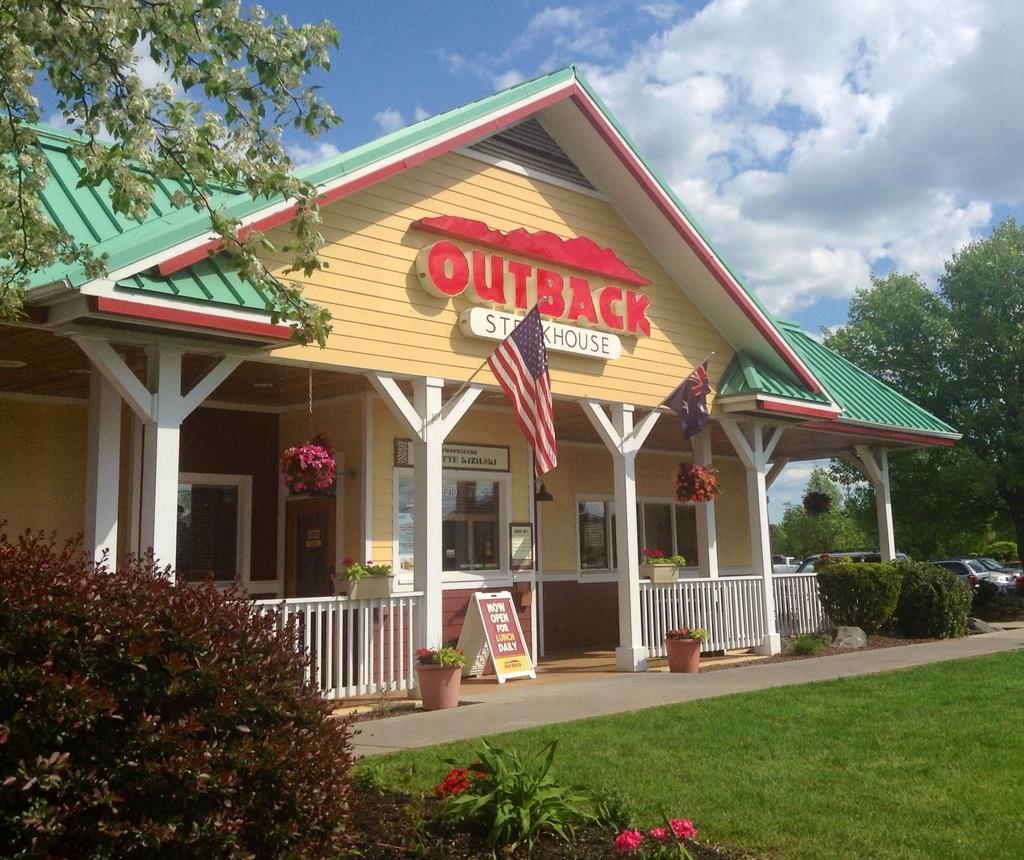Could you give a brief overview of what you see in this image? Here we can see grass, plants, flowers, cars, flags, boards, fence, trees, and a house. In the background there is sky with clouds. 